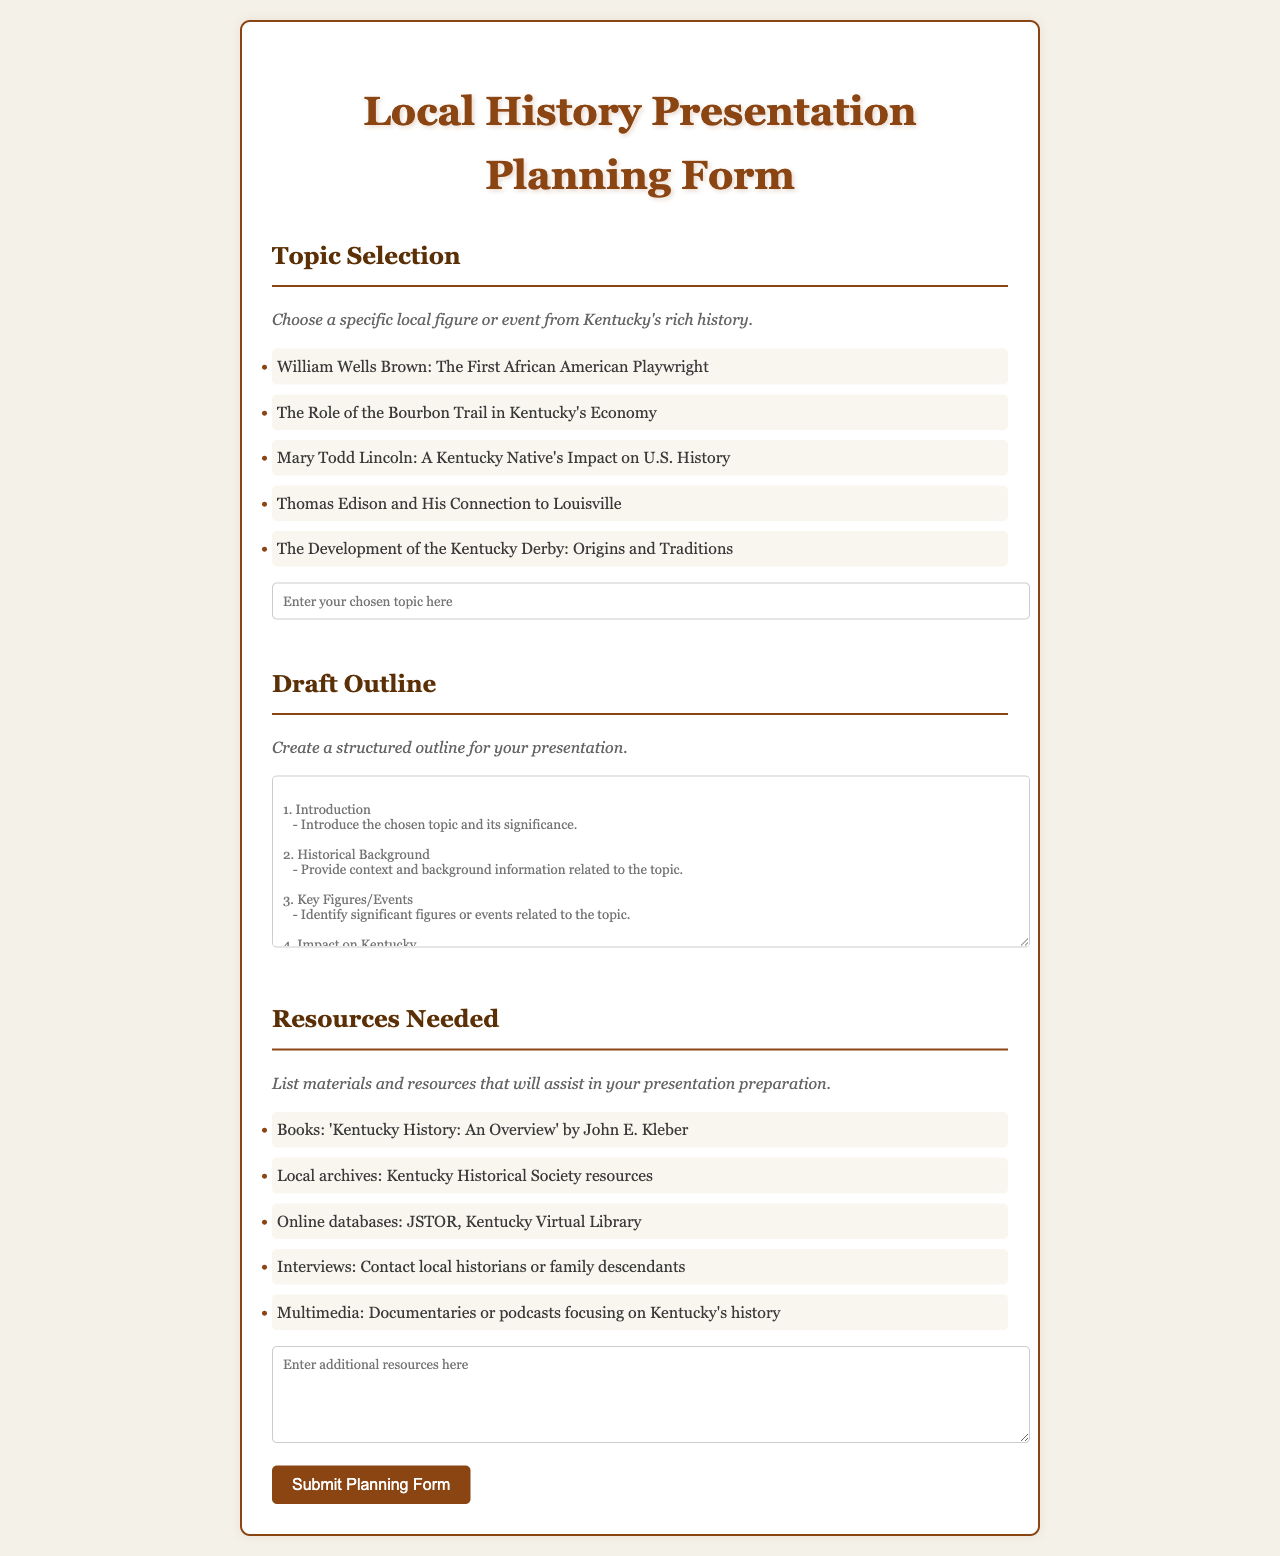What is the title of the form? The title of the form is stated prominently at the top of the document.
Answer: Local History Presentation Planning Form What is one of the topics that can be selected? The document lists several topics, and one is provided as an example.
Answer: William Wells Brown: The First African American Playwright How many sections are there in the form? The form consists of three main sections based on its structure.
Answer: Three What is the first resource listed for the presentation preparation? The first listed resource in the section is aimed at providing background material.
Answer: Books: 'Kentucky History: An Overview' by John E. Kleber What is required in the Draft Outline section? The Draft Outline section has specific instructions for structuring information.
Answer: Create a structured outline for your presentation What color is the background of the document? The document's style specifies a color used for the background.
Answer: Light beige What does the button saying “Submit Planning Form” do? The button in the form serves a functional purpose related to the document's intent.
Answer: Submits the planning form What type of font is used throughout the document? The document specifies a particular font family to maintain style consistency.
Answer: Georgia What does the instruction under Topic Selection suggest? The instruction for selecting a topic gives guidance on the focus of the presentation.
Answer: Choose a specific local figure or event from Kentucky's rich history 